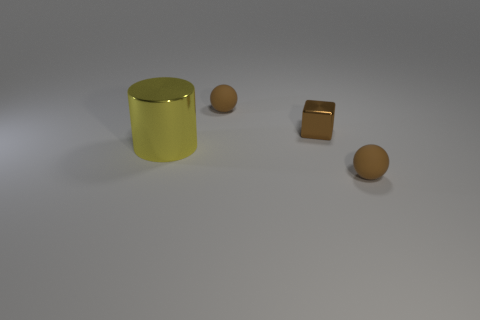Are the large yellow object and the small brown sphere behind the yellow shiny cylinder made of the same material?
Keep it short and to the point. No. Are there any other things that have the same shape as the big yellow shiny object?
Your response must be concise. No. Does the large yellow thing in front of the brown metal cube have the same material as the block?
Provide a succinct answer. Yes. Are there any rubber things that have the same color as the cube?
Offer a terse response. Yes. Are any metal balls visible?
Offer a very short reply. No. Does the matte sphere that is behind the yellow metallic cylinder have the same size as the yellow shiny object?
Your answer should be compact. No. Is the number of big yellow objects less than the number of blue shiny cylinders?
Your response must be concise. No. The rubber thing that is to the right of the small brown rubber object that is behind the small brown object in front of the tiny cube is what shape?
Offer a very short reply. Sphere. Is there a thing that has the same material as the big cylinder?
Provide a short and direct response. Yes. Is the color of the rubber ball behind the small block the same as the matte thing that is in front of the small block?
Keep it short and to the point. Yes. 